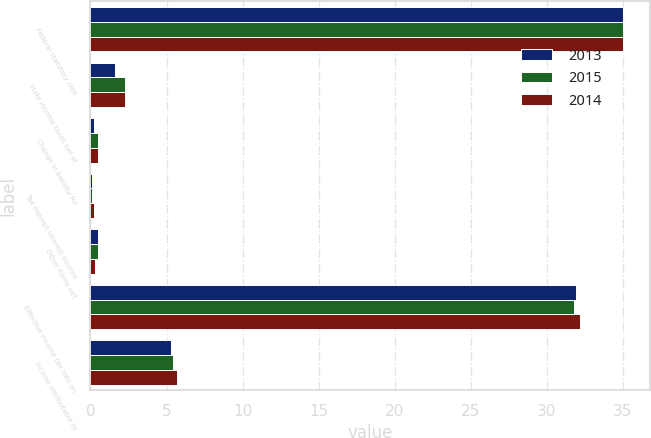<chart> <loc_0><loc_0><loc_500><loc_500><stacked_bar_chart><ecel><fcel>Federal statutory rate<fcel>State income taxes net of<fcel>Change in liability for<fcel>Tax exempt interest income<fcel>Other items net<fcel>Effective income tax rate on<fcel>Income attributable to<nl><fcel>2013<fcel>35<fcel>1.6<fcel>0.2<fcel>0.1<fcel>0.5<fcel>31.9<fcel>5.3<nl><fcel>2015<fcel>35<fcel>2.3<fcel>0.5<fcel>0.1<fcel>0.5<fcel>31.8<fcel>5.4<nl><fcel>2014<fcel>35<fcel>2.3<fcel>0.5<fcel>0.2<fcel>0.3<fcel>32.2<fcel>5.7<nl></chart> 